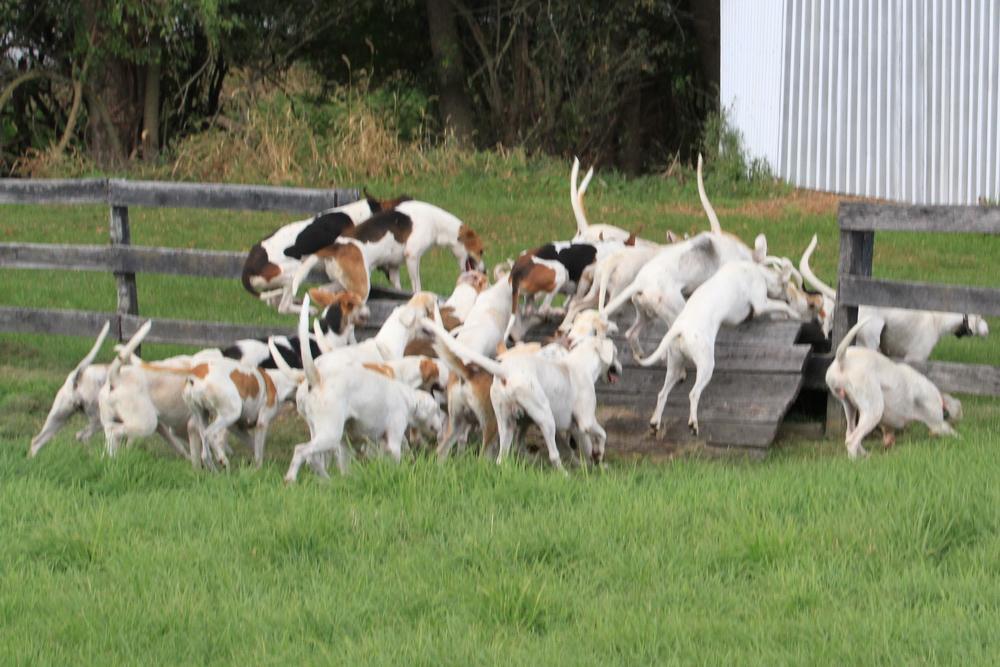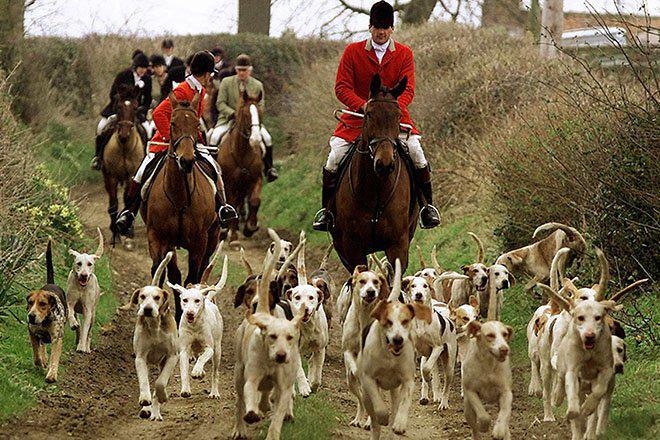The first image is the image on the left, the second image is the image on the right. For the images displayed, is the sentence "Left image includes a person with a group of dogs." factually correct? Answer yes or no. No. The first image is the image on the left, the second image is the image on the right. Assess this claim about the two images: "At least one human face is visible.". Correct or not? Answer yes or no. Yes. 